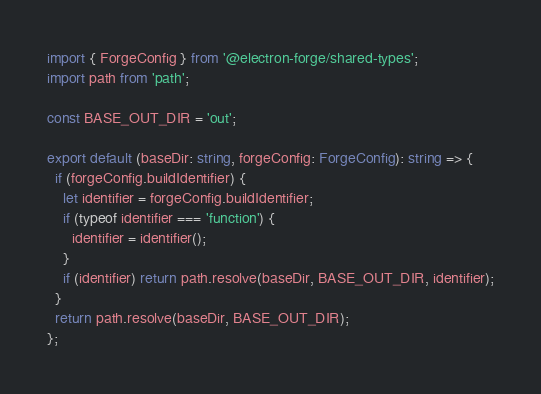Convert code to text. <code><loc_0><loc_0><loc_500><loc_500><_TypeScript_>import { ForgeConfig } from '@electron-forge/shared-types';
import path from 'path';

const BASE_OUT_DIR = 'out';

export default (baseDir: string, forgeConfig: ForgeConfig): string => {
  if (forgeConfig.buildIdentifier) {
    let identifier = forgeConfig.buildIdentifier;
    if (typeof identifier === 'function') {
      identifier = identifier();
    }
    if (identifier) return path.resolve(baseDir, BASE_OUT_DIR, identifier);
  }
  return path.resolve(baseDir, BASE_OUT_DIR);
};
</code> 